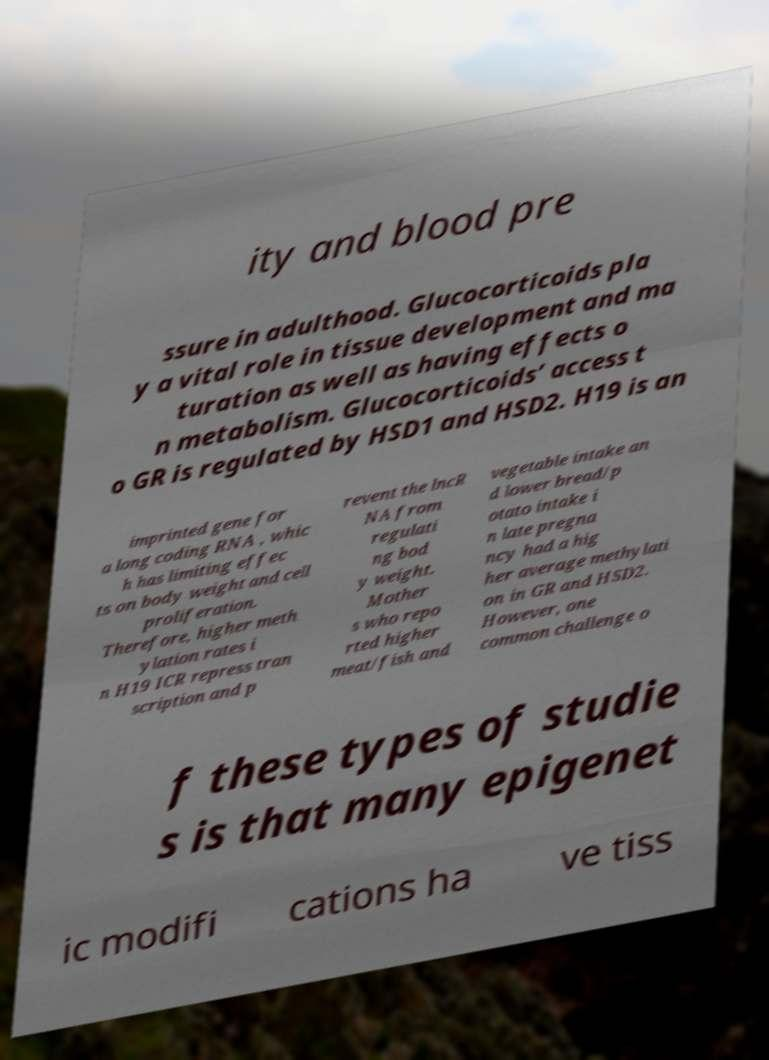Please read and relay the text visible in this image. What does it say? ity and blood pre ssure in adulthood. Glucocorticoids pla y a vital role in tissue development and ma turation as well as having effects o n metabolism. Glucocorticoids’ access t o GR is regulated by HSD1 and HSD2. H19 is an imprinted gene for a long coding RNA , whic h has limiting effec ts on body weight and cell proliferation. Therefore, higher meth ylation rates i n H19 ICR repress tran scription and p revent the lncR NA from regulati ng bod y weight. Mother s who repo rted higher meat/fish and vegetable intake an d lower bread/p otato intake i n late pregna ncy had a hig her average methylati on in GR and HSD2. However, one common challenge o f these types of studie s is that many epigenet ic modifi cations ha ve tiss 